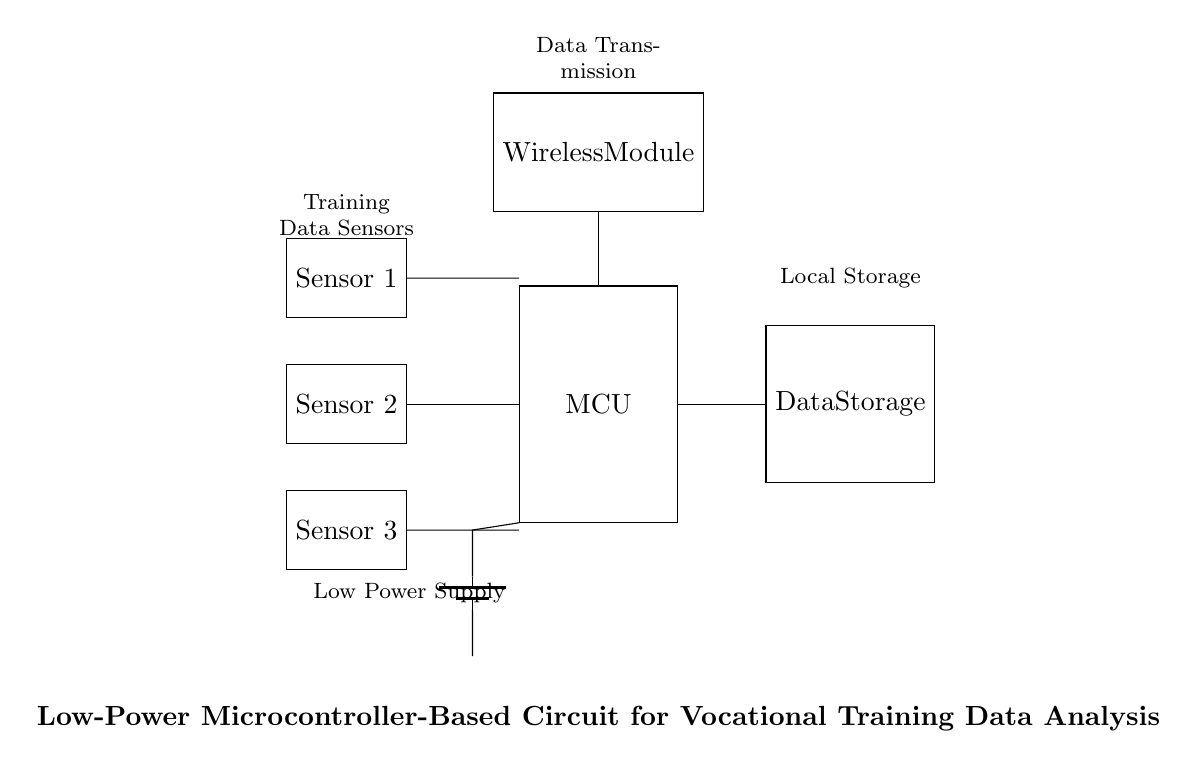What is the main component of the circuit? The main component is the microcontroller, which is represented as "MCU" in the diagram. It serves as the central processing unit for collecting and analyzing data.
Answer: MCU How many sensors are present in the circuit? There are three sensors connected to the microcontroller, as indicated by the three rectangles labeled "Sensor 1," "Sensor 2," and "Sensor 3."
Answer: Three What does the wireless module do? The wireless module is used for data transmission, allowing the microcontroller to send processed data wirelessly. It's labeled as "Wireless Module" in the circuit.
Answer: Data Transmission What type of power supply is used in this circuit? The circuit uses a battery as the power supply, which is depicted as "battery1" in the diagram, providing low power to the components.
Answer: Low Power Supply Why do the sensors connect to the microcontroller? The sensors connect to the microcontroller to provide training data for analysis. This design allows the MCU to process real-time data coming from the sensors.
Answer: Data Collection How does data storage connect to the circuit? The data storage unit is connected to the microcontroller through a direct line, indicating that the processed data from the MCU is sent to the "Data Storage" unit for further analysis.
Answer: Direct Connection 